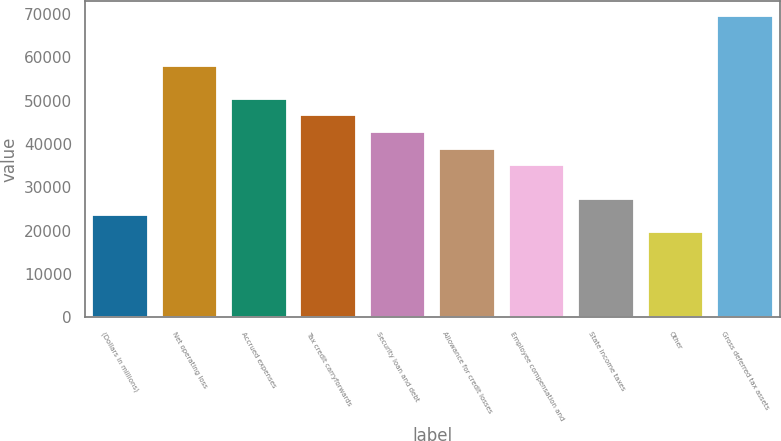Convert chart to OTSL. <chart><loc_0><loc_0><loc_500><loc_500><bar_chart><fcel>(Dollars in millions)<fcel>Net operating loss<fcel>Accrued expenses<fcel>Tax credit carryforwards<fcel>Security loan and debt<fcel>Allowance for credit losses<fcel>Employee compensation and<fcel>State income taxes<fcel>Other<fcel>Gross deferred tax assets<nl><fcel>23599.4<fcel>58118<fcel>50447.2<fcel>46611.8<fcel>42776.4<fcel>38941<fcel>35105.6<fcel>27434.8<fcel>19764<fcel>69624.2<nl></chart> 